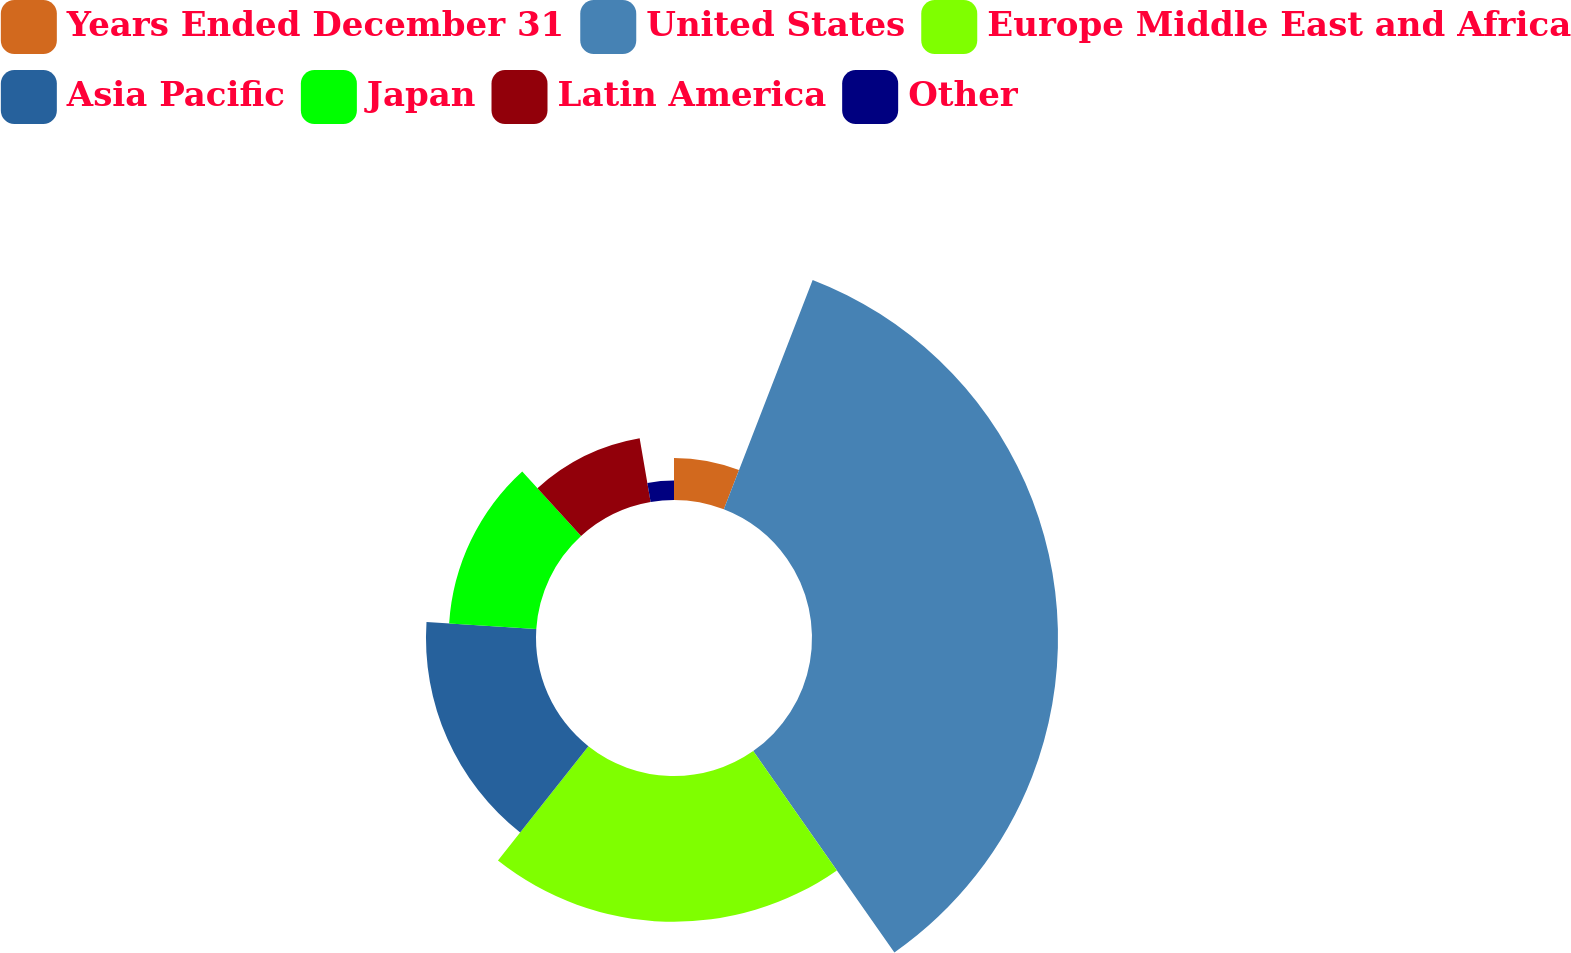Convert chart to OTSL. <chart><loc_0><loc_0><loc_500><loc_500><pie_chart><fcel>Years Ended December 31<fcel>United States<fcel>Europe Middle East and Africa<fcel>Asia Pacific<fcel>Japan<fcel>Latin America<fcel>Other<nl><fcel>5.88%<fcel>34.39%<fcel>20.38%<fcel>15.38%<fcel>12.21%<fcel>9.05%<fcel>2.71%<nl></chart> 